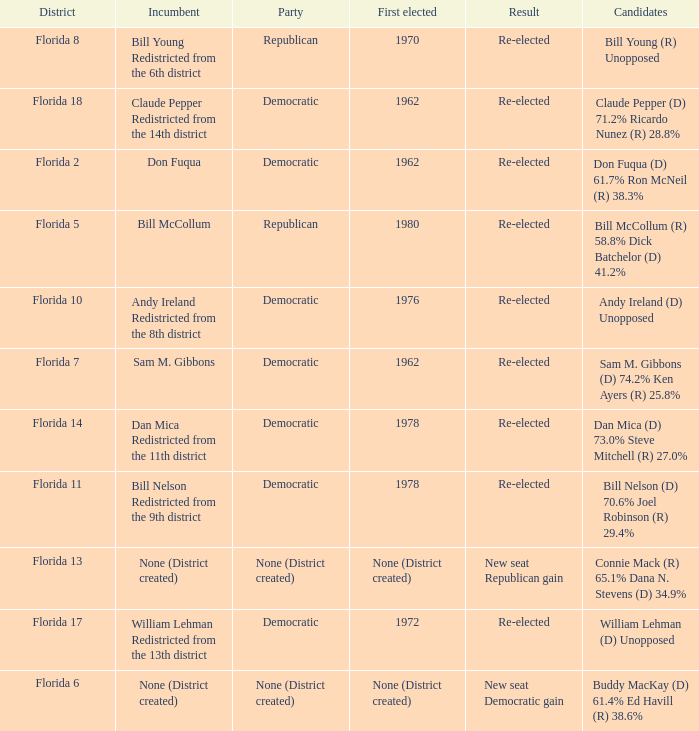 how many candidates with result being new seat democratic gain 1.0. 